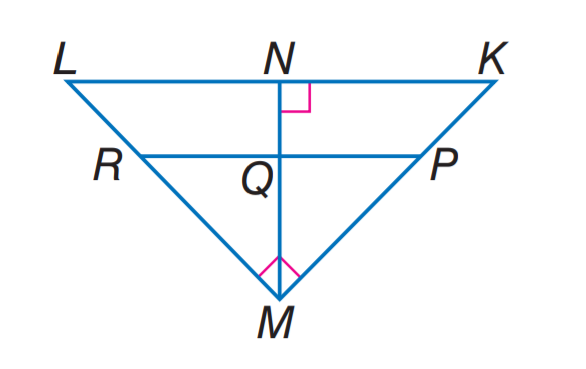Answer the mathemtical geometry problem and directly provide the correct option letter.
Question: If P R \parallel K L, K N = 9, L N = 16, and P M = 2K P, find M L.
Choices: A: 15 B: 16 C: 20 D: 24 C 